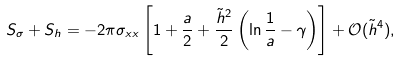<formula> <loc_0><loc_0><loc_500><loc_500>S _ { \sigma } + S _ { h } = - 2 \pi \sigma _ { x x } \left [ 1 + \frac { a } { 2 } + \frac { \tilde { h } ^ { 2 } } { 2 } \left ( \ln \frac { 1 } { a } - \gamma \right ) \right ] + \mathcal { O } ( \tilde { h } ^ { 4 } ) ,</formula> 